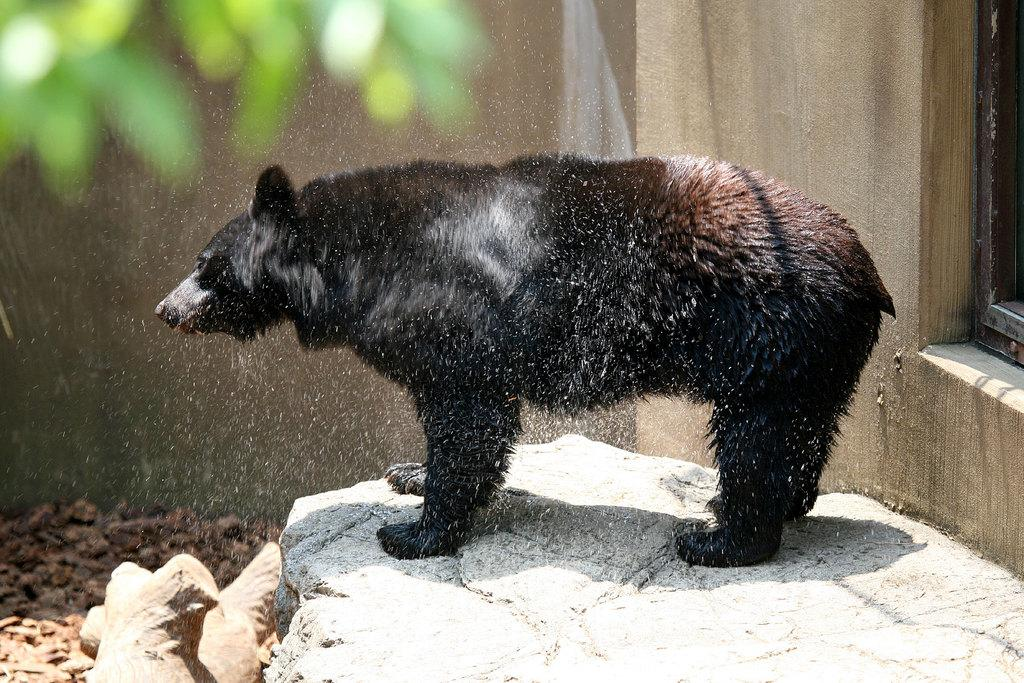What is the main subject in the center of the image? There is a bear in the center of the image. Where is the bear located? The bear is on a rock. What can be seen in the background of the image? There is a window, leaves, and logs visible in the background of the image. What type of powder is being used by the bird in the image? There is no bird or powder present in the image; it features a bear on a rock with a background containing a window, leaves, and logs. 